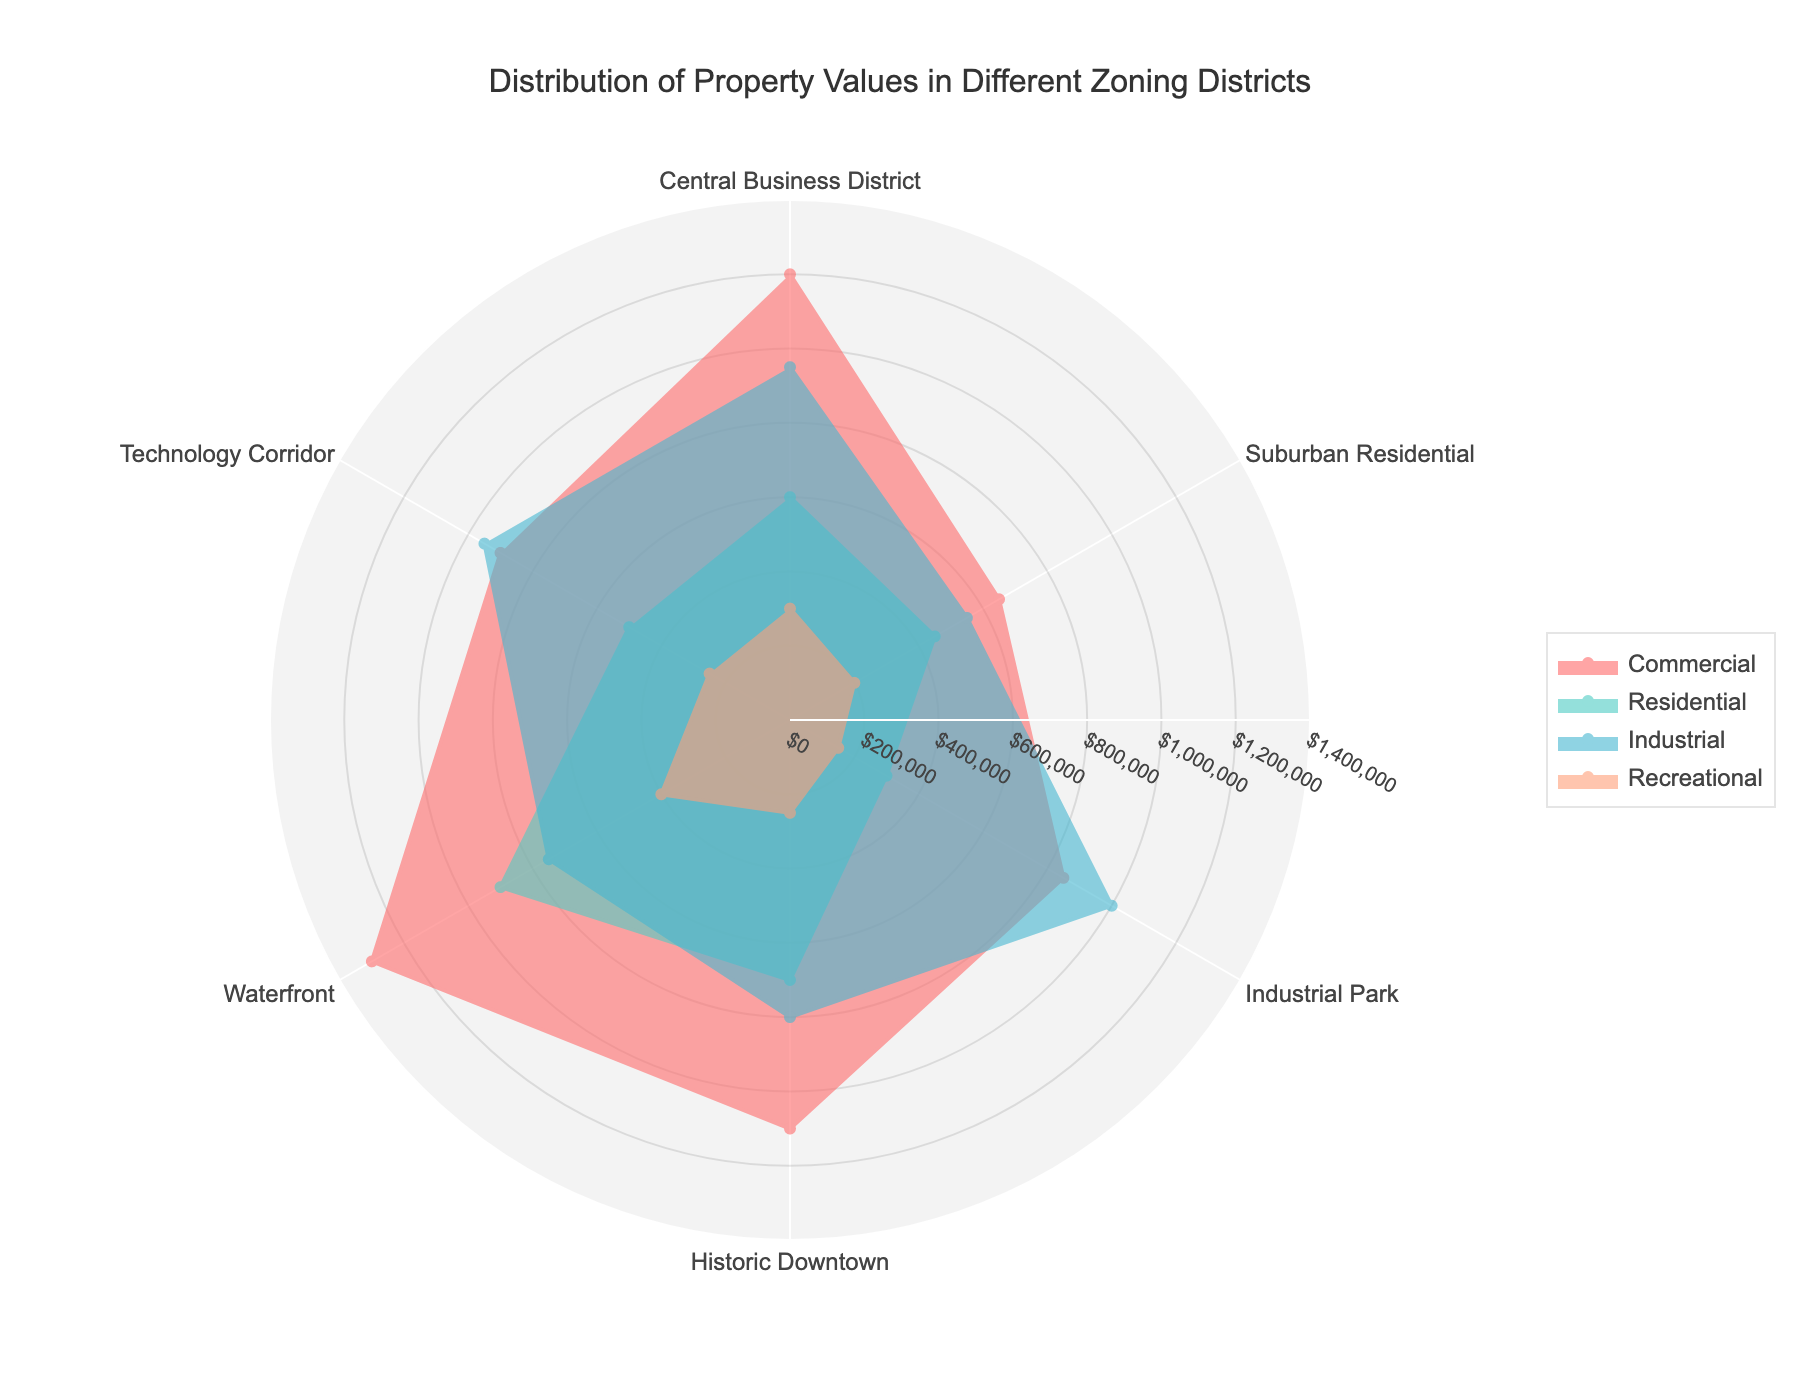What's the title of the chart? The title of the chart is located at the top and is meant to summarize the content. It reads "Distribution of Property Values in Different Zoning Districts."
Answer: Distribution of Property Values in Different Zoning Districts How many zoning districts are shown in the chart? Each spoke of the radar chart represents a different zoning district. Count the labels on the axes: Central Business District, Suburban Residential, Industrial Park, Historic Downtown, Waterfront, and Technology Corridor.
Answer: 6 Which district has the highest property value for the Commercial category? Look for the longest 'spoke' in the Commercial trace, which corresponds to its highest value. The Commercial trace with the highest value extends the furthest on the radar plot.
Answer: Waterfront Compare the Industrial values of the Central Business District and Industrial Park. Which is higher and by how much? Identify the 'spoke' lengths for Industrial in both districts on the chart. The Central Business District has a value of 950,000, and Industrial Park has a value of 1,000,000. Subtract the smaller value from the larger one.
Answer: Industrial Park is higher by 50,000 What category is the least valuable in Suburban Residential? Look at the 'spokes' for Suburban Residential and identify the shortest one, which indicates the least value.
Answer: Recreational Which district has the most balanced property values across all categories? Compare the spread of values across all categories for each district. The district with the smallest differences between its highest and lowest values is the most balanced.
Answer: Suburban Residential What is the difference between the highest and lowest property values for Historic Downtown? Identify the maximum and minimum values for Historic Downtown, which are 1,100,000 and 250,000 respectively, then subtract the minimum from the maximum.
Answer: 850,000 If you were to invest in recreational property, which district would you choose based on the highest value? Find the 'spoke' that extends the furthest in Recreational category.
Answer: Waterfront Are the property values for Industrial in Central Business District higher or lower than those for Residential in Waterfront? Compare the values visually. Industrial in Central Business District is 950,000, and Residential in Waterfront is 900,000.
Answer: Higher Which two districts have the most similar property values for the Technology Corridor and Suburban Residential categories? Compare the traces for Technology Corridor and Suburban Residential to find which districts have similar 'spoke' lengths in these categories.
Answer: Technology Corridor and Waterfront 